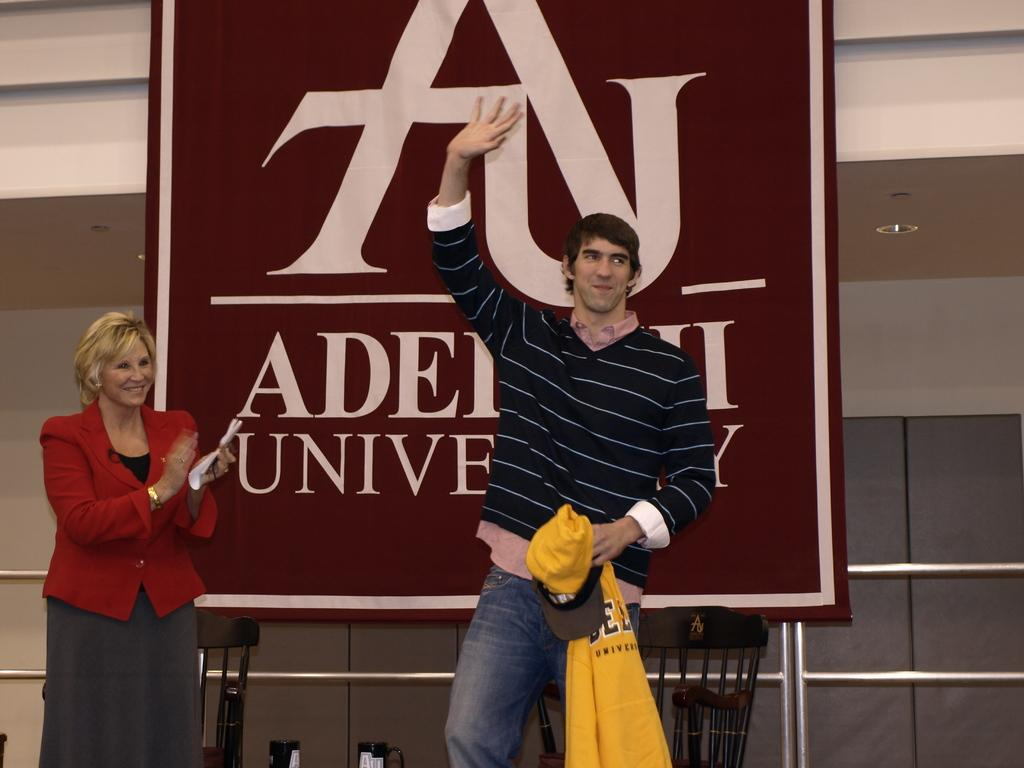What is happening in the image? There are people standing in the image. What is the woman holding in her hand? The woman is holding papers in her hand. What is the man holding in his hand? The man is holding a cap and shirt in his hand. What can be seen in the background of the image? There is a banner visible in the image. How does the cloth rub against the quiet person in the image? There is no cloth or quiet person present in the image. 